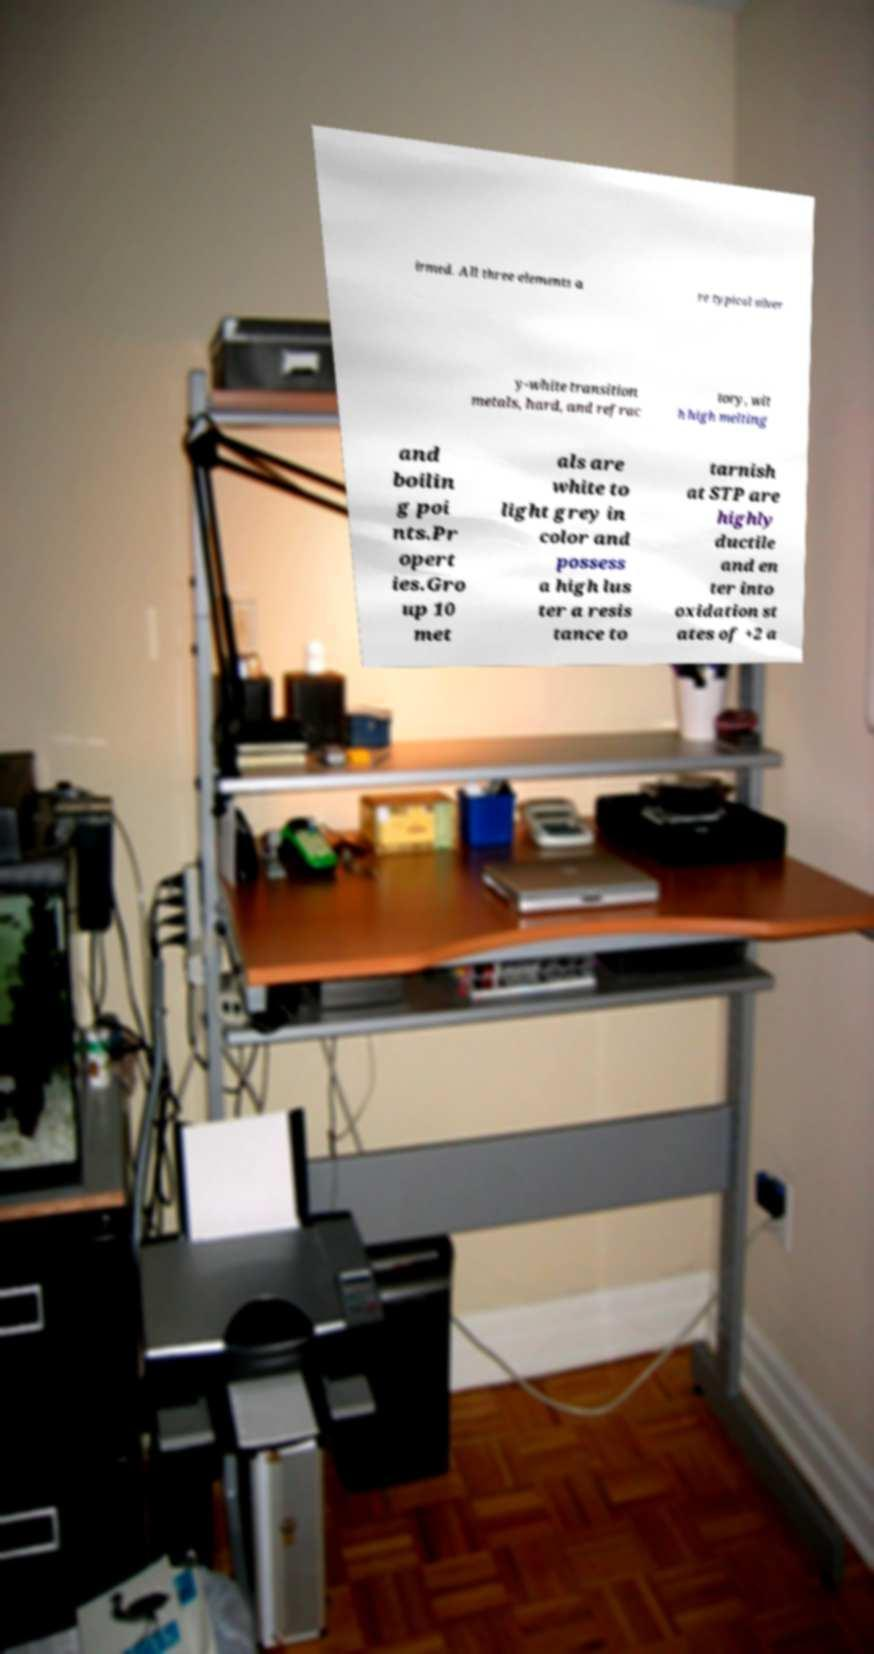Can you read and provide the text displayed in the image?This photo seems to have some interesting text. Can you extract and type it out for me? irmed. All three elements a re typical silver y-white transition metals, hard, and refrac tory, wit h high melting and boilin g poi nts.Pr opert ies.Gro up 10 met als are white to light grey in color and possess a high lus ter a resis tance to tarnish at STP are highly ductile and en ter into oxidation st ates of +2 a 